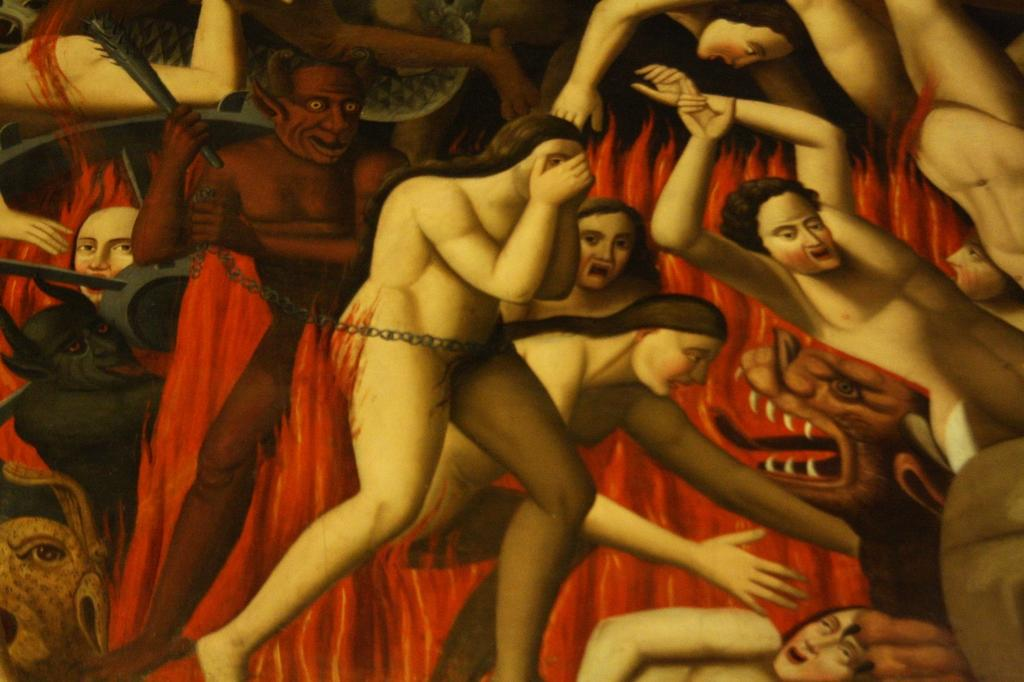What is the main subject of the image? The image contains a painting. What scene is depicted in the painting? The painting depicts a scene of hell. What are the people in the painting doing to each other? The people in the painting are beating other people. What is the state of the people being beaten? The people being beaten are nude. What element is present in the painting that contributes to the depiction of hell? There is fire present in the painting. What type of dirt can be seen on the prison floor in the image? There is no prison or dirt present in the image; it contains a painting depicting a scene of hell. 